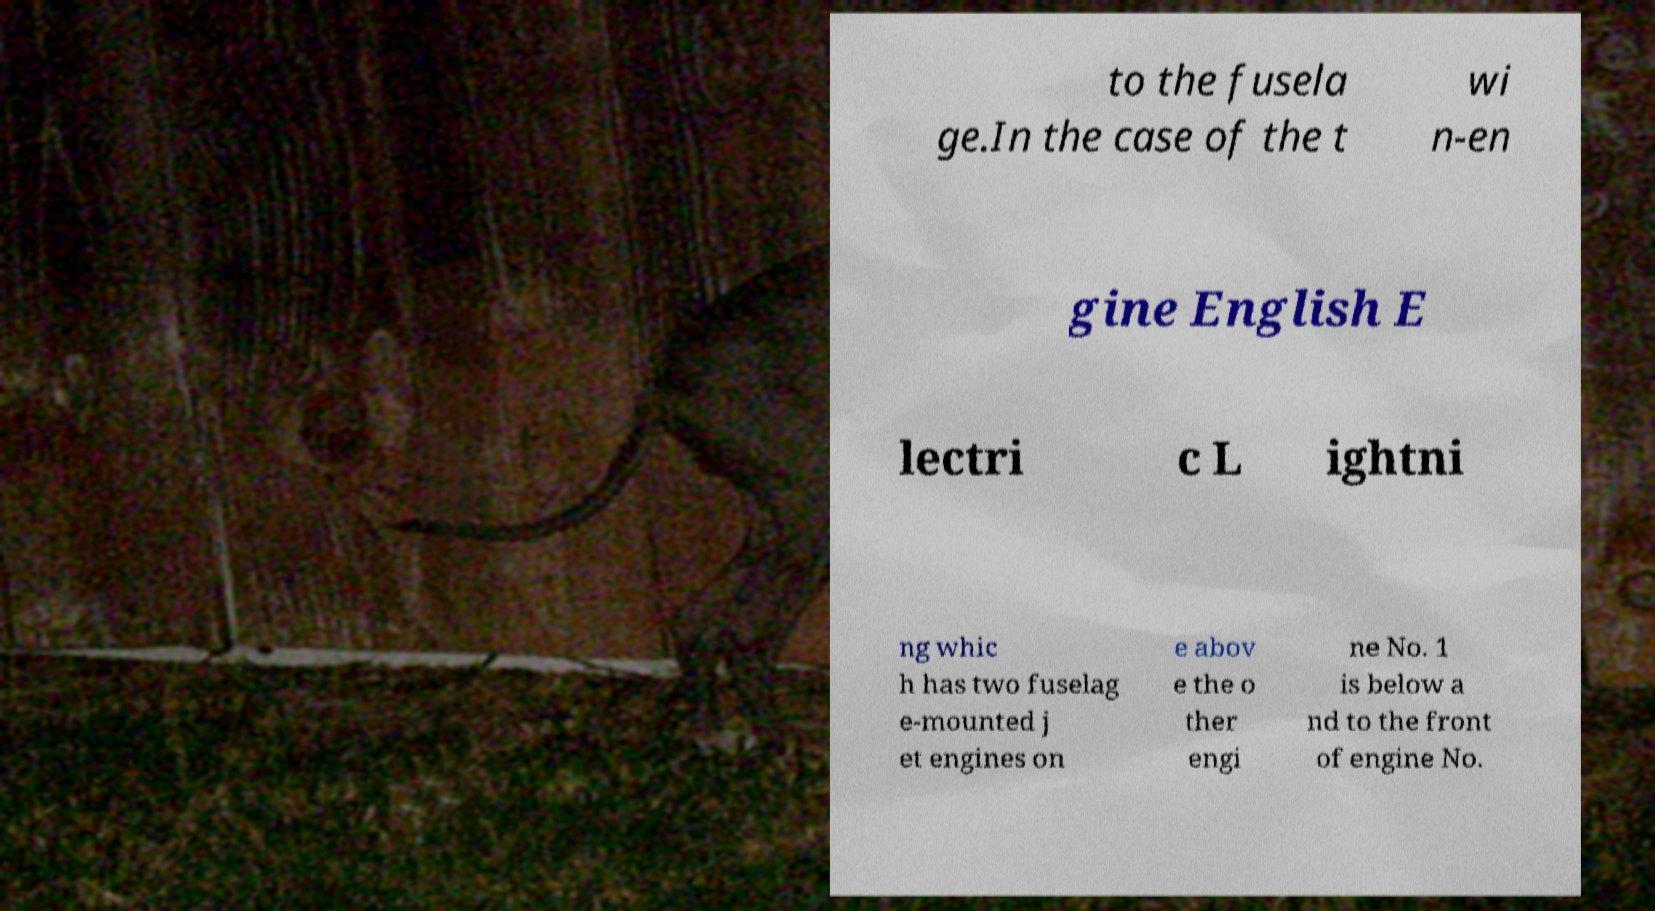Please identify and transcribe the text found in this image. to the fusela ge.In the case of the t wi n-en gine English E lectri c L ightni ng whic h has two fuselag e-mounted j et engines on e abov e the o ther engi ne No. 1 is below a nd to the front of engine No. 